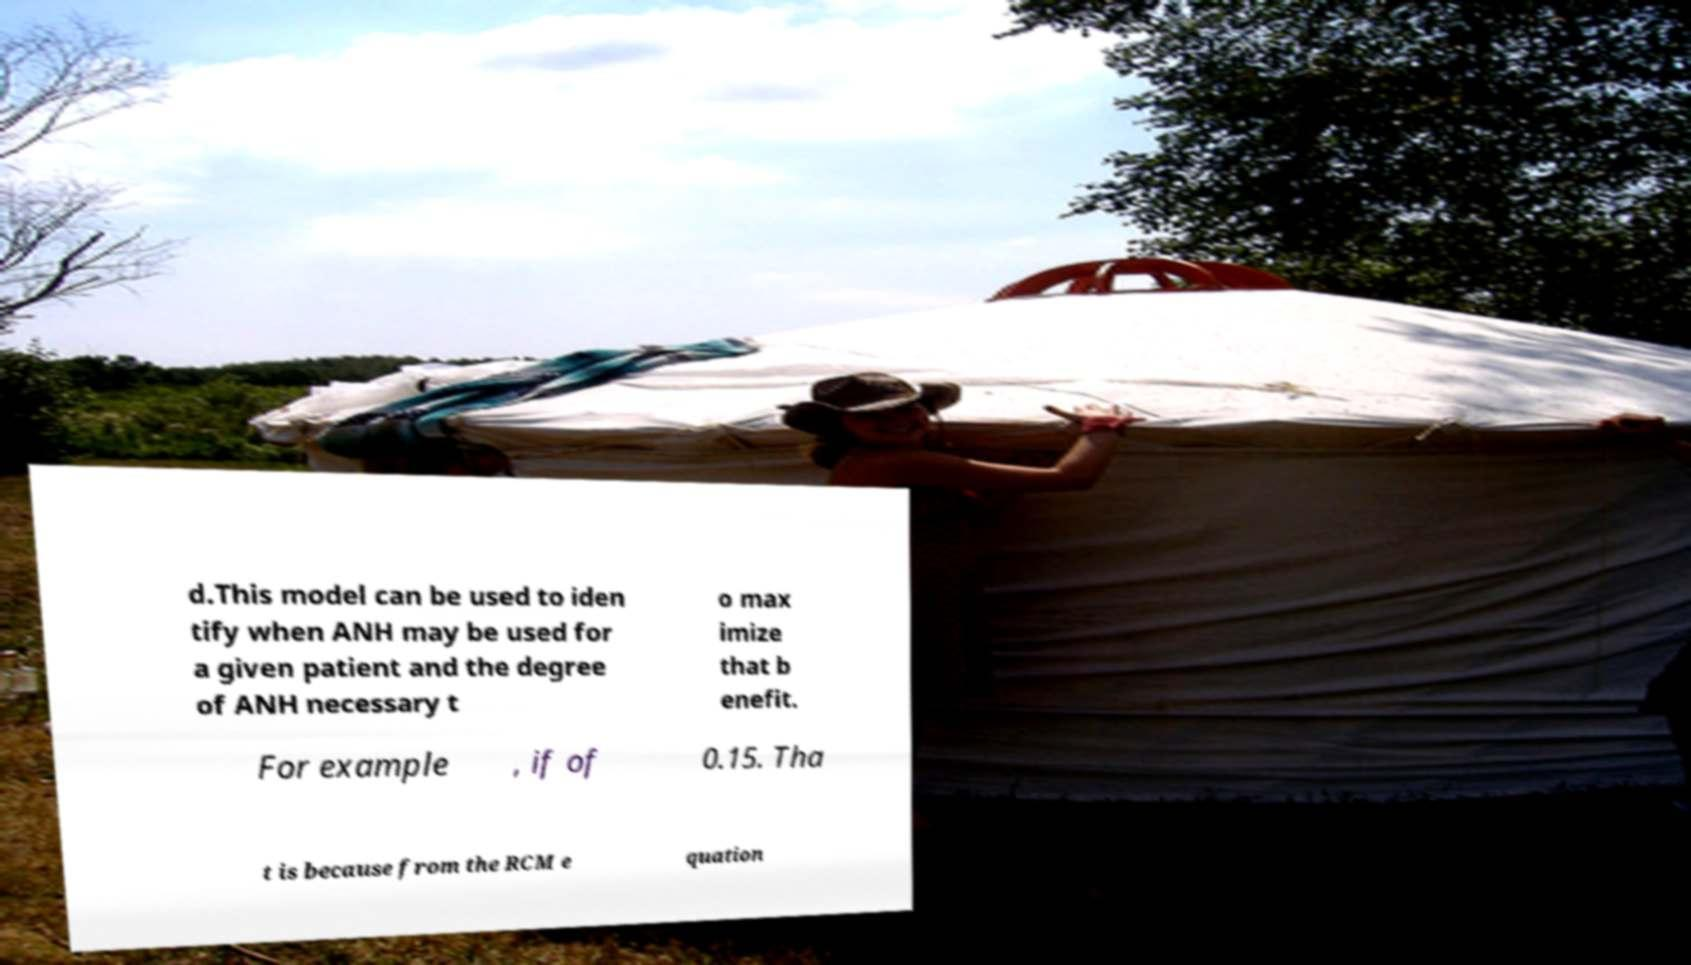What messages or text are displayed in this image? I need them in a readable, typed format. d.This model can be used to iden tify when ANH may be used for a given patient and the degree of ANH necessary t o max imize that b enefit. For example , if of 0.15. Tha t is because from the RCM e quation 